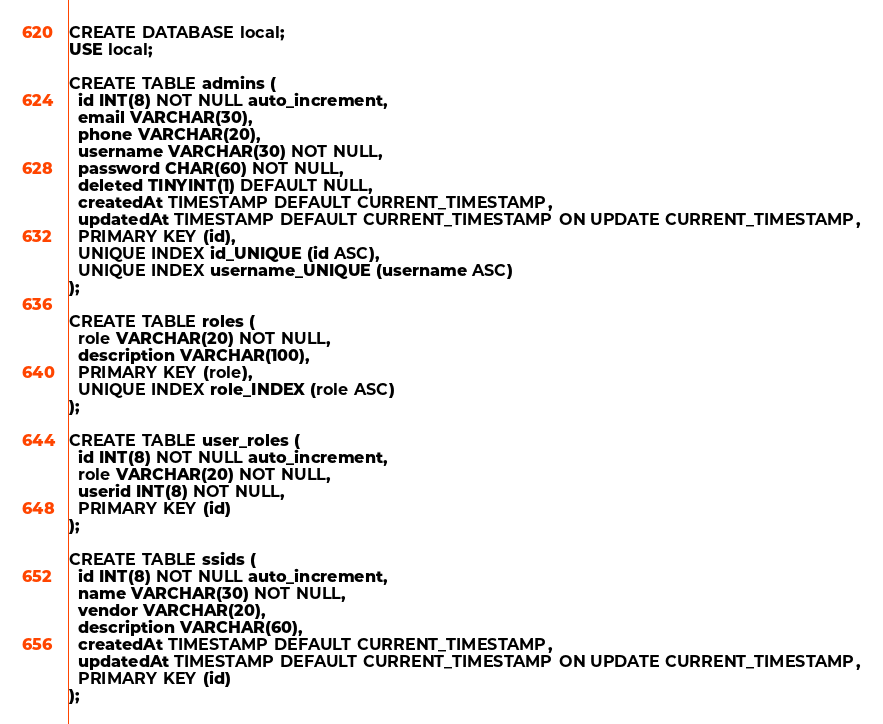<code> <loc_0><loc_0><loc_500><loc_500><_SQL_>CREATE DATABASE local;
USE local;

CREATE TABLE admins (
  id INT(8) NOT NULL auto_increment,
  email VARCHAR(30),
  phone VARCHAR(20),
  username VARCHAR(30) NOT NULL,
  password CHAR(60) NOT NULL,
  deleted TINYINT(1) DEFAULT NULL,
  createdAt TIMESTAMP DEFAULT CURRENT_TIMESTAMP,
  updatedAt TIMESTAMP DEFAULT CURRENT_TIMESTAMP ON UPDATE CURRENT_TIMESTAMP,
  PRIMARY KEY (id),
  UNIQUE INDEX id_UNIQUE (id ASC),
  UNIQUE INDEX username_UNIQUE (username ASC)
);

CREATE TABLE roles (
  role VARCHAR(20) NOT NULL,
  description VARCHAR(100),
  PRIMARY KEY (role),
  UNIQUE INDEX role_INDEX (role ASC)
);

CREATE TABLE user_roles (
  id INT(8) NOT NULL auto_increment,
  role VARCHAR(20) NOT NULL,
  userid INT(8) NOT NULL,
  PRIMARY KEY (id)
);

CREATE TABLE ssids (
  id INT(8) NOT NULL auto_increment,
  name VARCHAR(30) NOT NULL,
  vendor VARCHAR(20),
  description VARCHAR(60),
  createdAt TIMESTAMP DEFAULT CURRENT_TIMESTAMP,
  updatedAt TIMESTAMP DEFAULT CURRENT_TIMESTAMP ON UPDATE CURRENT_TIMESTAMP,
  PRIMARY KEY (id)
);</code> 